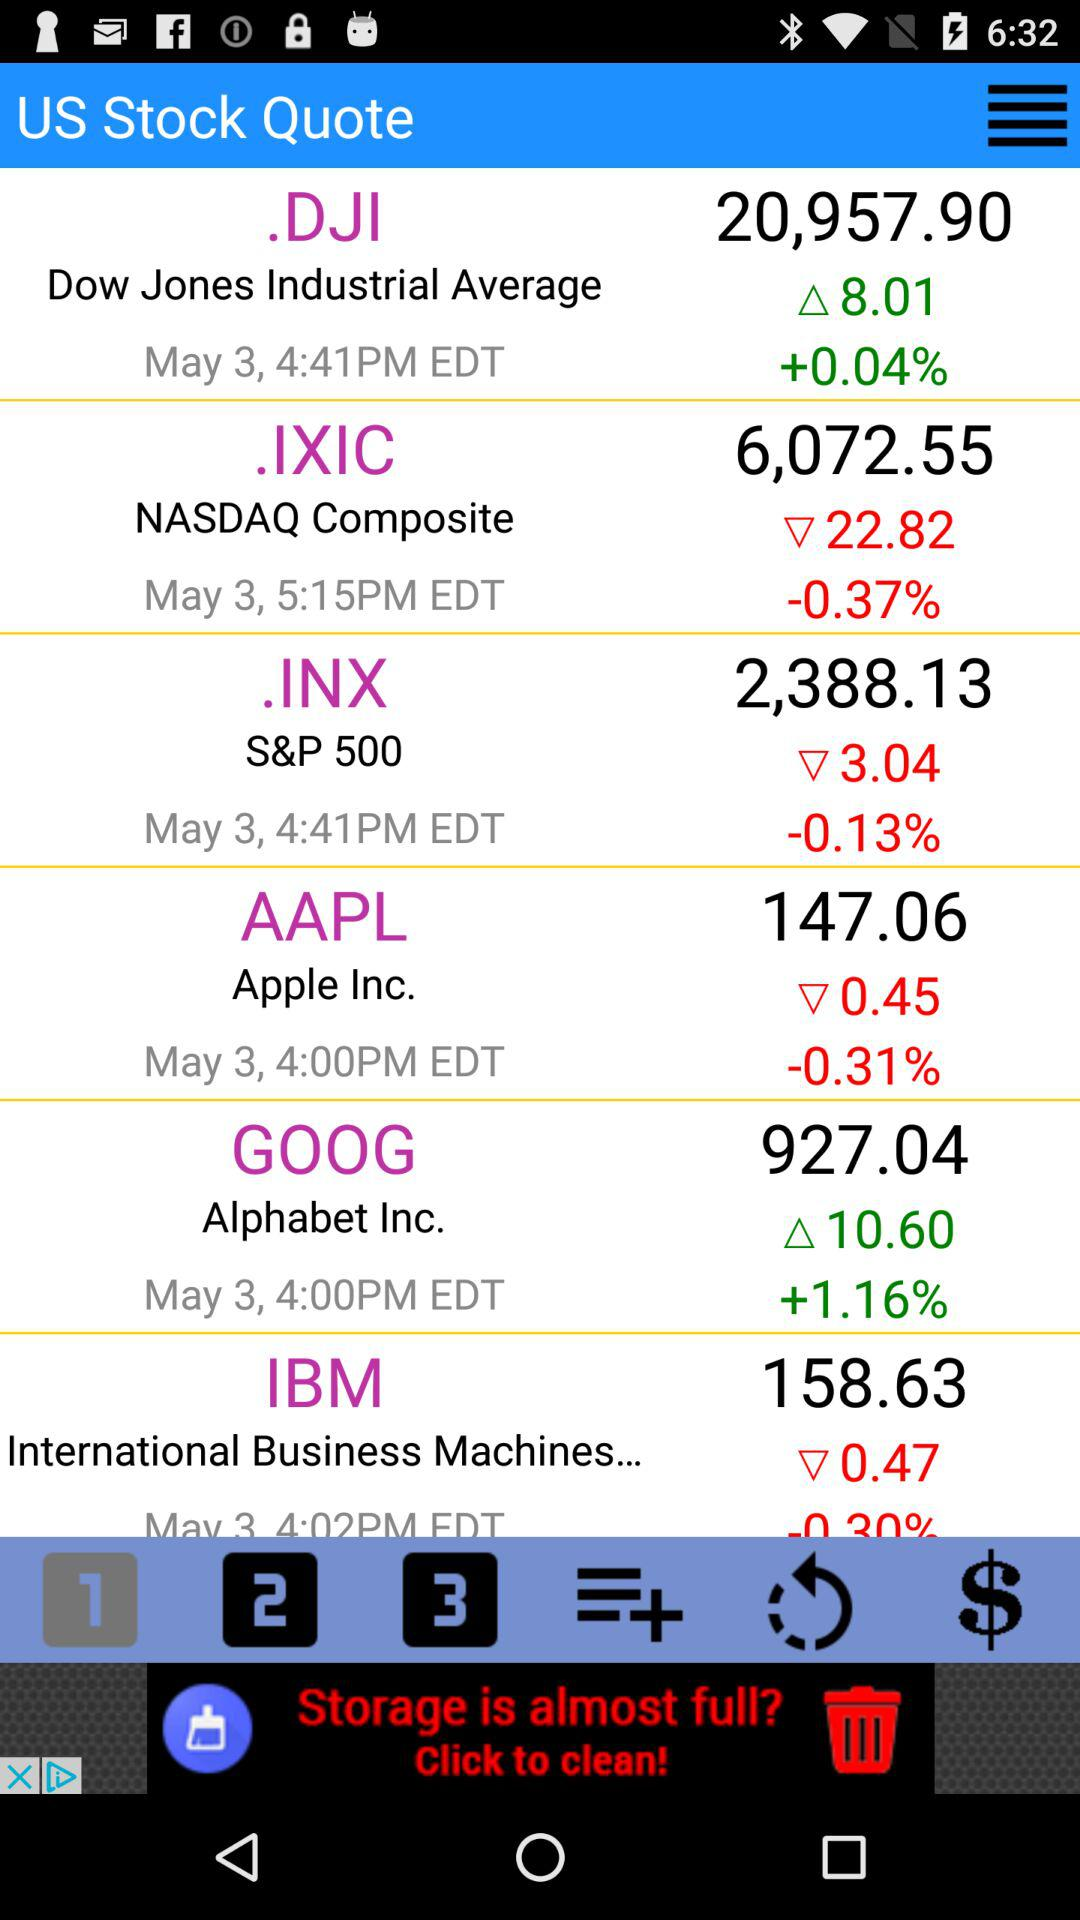What is the percentage gain on.DJI stock? The percentage gain on.DJI stock is more than 0.04. 